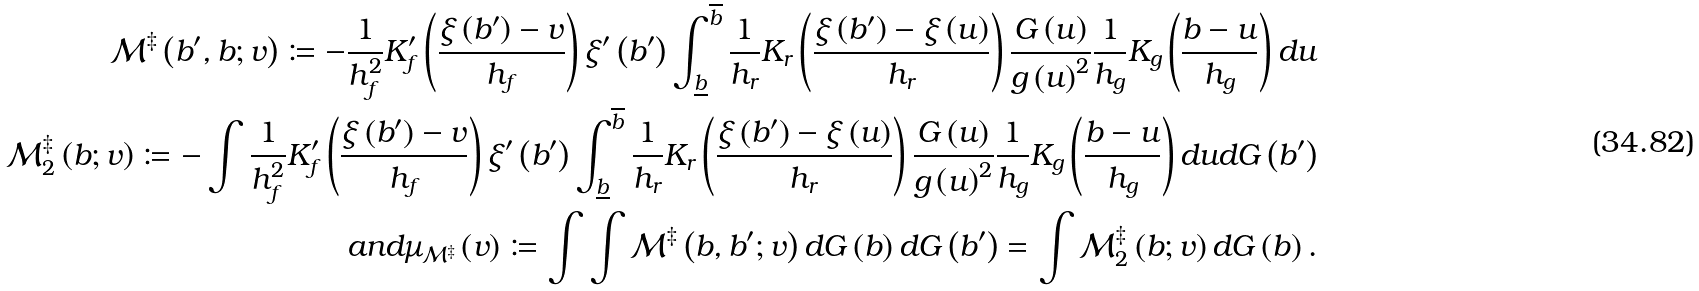<formula> <loc_0><loc_0><loc_500><loc_500>\mathcal { M } ^ { \ddagger } \left ( b ^ { \prime } , b ; v \right ) \coloneqq - \frac { 1 } { h _ { f } ^ { 2 } } K _ { f } ^ { \prime } \left ( \frac { \xi \left ( b ^ { \prime } \right ) - v } { h _ { f } } \right ) \xi ^ { \prime } \left ( b ^ { \prime } \right ) \int _ { \underline { b } } ^ { \overline { b } } \frac { 1 } { h _ { r } } K _ { r } \left ( \frac { \xi \left ( b ^ { \prime } \right ) - \xi \left ( u \right ) } { h _ { r } } \right ) \frac { G \left ( u \right ) } { g \left ( u \right ) ^ { 2 } } \frac { 1 } { h _ { g } } K _ { g } \left ( \frac { b - u } { h _ { g } } \right ) d u \\ \mathcal { M } _ { 2 } ^ { \ddagger } \left ( b ; v \right ) \coloneqq - \int \frac { 1 } { h _ { f } ^ { 2 } } K _ { f } ^ { \prime } \left ( \frac { \xi \left ( b ^ { \prime } \right ) - v } { h _ { f } } \right ) \xi ^ { \prime } \left ( b ^ { \prime } \right ) \int _ { \underline { b } } ^ { \overline { b } } \frac { 1 } { h _ { r } } K _ { r } \left ( \frac { \xi \left ( b ^ { \prime } \right ) - \xi \left ( u \right ) } { h _ { r } } \right ) \frac { G \left ( u \right ) } { g \left ( u \right ) ^ { 2 } } \frac { 1 } { h _ { g } } K _ { g } \left ( \frac { b - u } { h _ { g } } \right ) d u d G \left ( b ^ { \prime } \right ) \\ a n d \mu _ { \mathcal { M } ^ { \ddagger } } \left ( v \right ) \coloneqq \int \int \mathcal { M } ^ { \ddagger } \left ( b , b ^ { \prime } ; v \right ) d G \left ( b \right ) d G \left ( b ^ { \prime } \right ) = \int \mathcal { M } _ { 2 } ^ { \ddagger } \left ( b ; v \right ) d G \left ( b \right ) .</formula> 